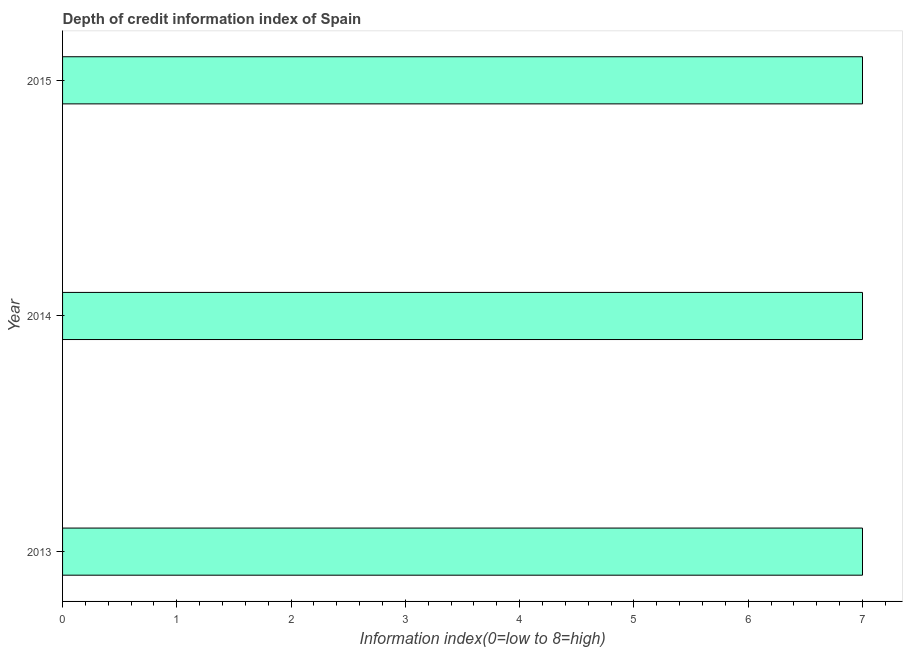Does the graph contain any zero values?
Keep it short and to the point. No. What is the title of the graph?
Offer a very short reply. Depth of credit information index of Spain. What is the label or title of the X-axis?
Your response must be concise. Information index(0=low to 8=high). What is the label or title of the Y-axis?
Provide a succinct answer. Year. Across all years, what is the maximum depth of credit information index?
Your response must be concise. 7. What is the difference between the depth of credit information index in 2013 and 2015?
Your response must be concise. 0. What is the median depth of credit information index?
Your answer should be compact. 7. In how many years, is the depth of credit information index greater than 1.6 ?
Make the answer very short. 3. Do a majority of the years between 2015 and 2014 (inclusive) have depth of credit information index greater than 5 ?
Provide a short and direct response. No. What is the difference between the highest and the second highest depth of credit information index?
Offer a very short reply. 0. Is the sum of the depth of credit information index in 2013 and 2014 greater than the maximum depth of credit information index across all years?
Offer a terse response. Yes. What is the difference between the highest and the lowest depth of credit information index?
Your answer should be compact. 0. Are all the bars in the graph horizontal?
Your answer should be very brief. Yes. What is the Information index(0=low to 8=high) in 2013?
Ensure brevity in your answer.  7. What is the Information index(0=low to 8=high) of 2014?
Ensure brevity in your answer.  7. What is the Information index(0=low to 8=high) of 2015?
Offer a very short reply. 7. What is the difference between the Information index(0=low to 8=high) in 2013 and 2014?
Your answer should be very brief. 0. What is the difference between the Information index(0=low to 8=high) in 2014 and 2015?
Make the answer very short. 0. What is the ratio of the Information index(0=low to 8=high) in 2013 to that in 2014?
Give a very brief answer. 1. What is the ratio of the Information index(0=low to 8=high) in 2014 to that in 2015?
Your answer should be very brief. 1. 